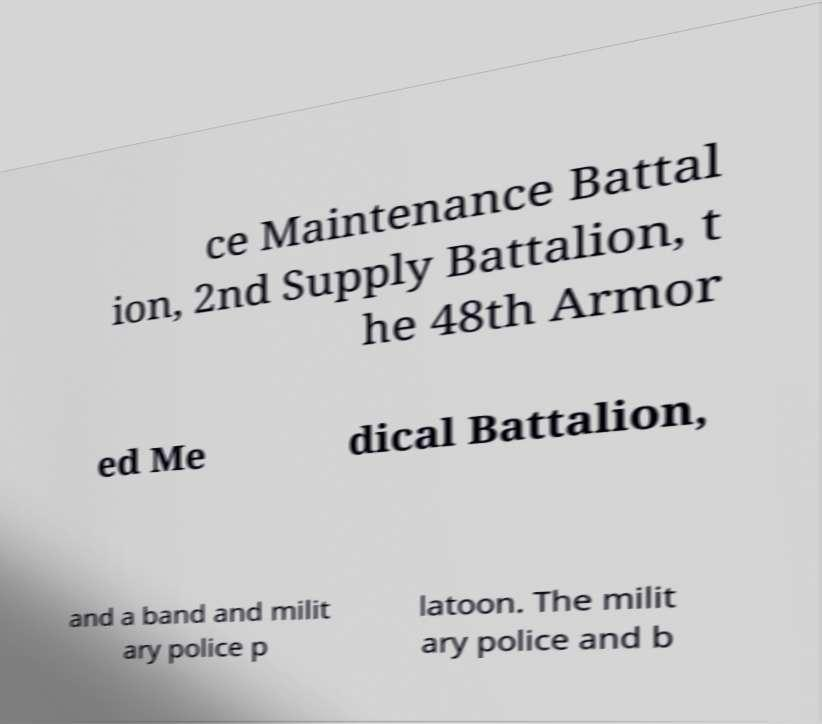Please identify and transcribe the text found in this image. ce Maintenance Battal ion, 2nd Supply Battalion, t he 48th Armor ed Me dical Battalion, and a band and milit ary police p latoon. The milit ary police and b 